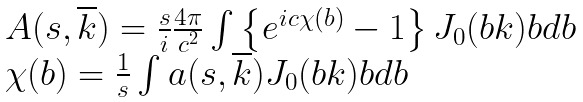Convert formula to latex. <formula><loc_0><loc_0><loc_500><loc_500>\begin{array} { l } A ( s , \overline { k } ) = \frac { s } { i } \frac { 4 \pi } { c ^ { 2 } } \int \left \{ e ^ { i c \chi ( b ) } - 1 \right \} J _ { 0 } ( b k ) b d b \\ \chi ( b ) = \frac { 1 } { s } \int a ( s , \overline { k } ) J _ { 0 } ( b k ) b d b \end{array}</formula> 